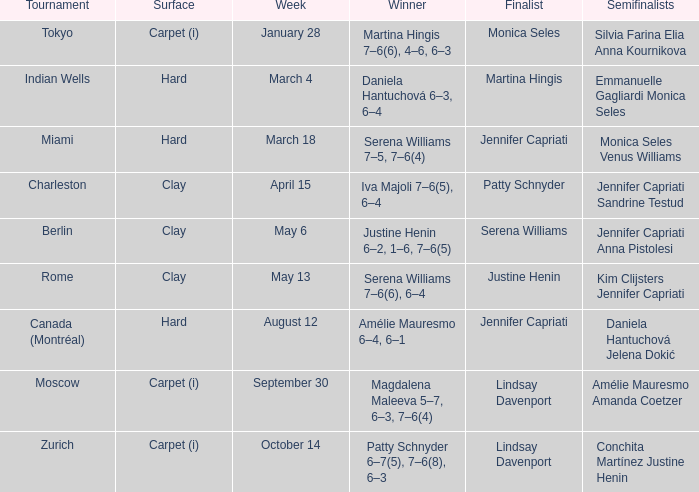What was the ground for finalist justine henin? Clay. 